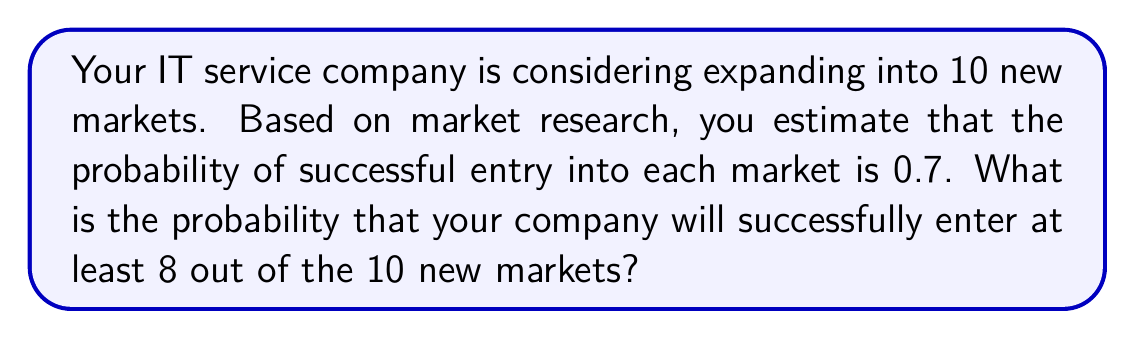Solve this math problem. This problem can be solved using the binomial distribution. Let's break it down step-by-step:

1) We have a binomial distribution with the following parameters:
   $n = 10$ (number of trials/markets)
   $p = 0.7$ (probability of success for each market)
   $q = 1 - p = 0.3$ (probability of failure for each market)

2) We want to find the probability of at least 8 successes. This means we need to calculate:
   $P(X \geq 8) = P(X = 8) + P(X = 9) + P(X = 10)$

3) The probability mass function for a binomial distribution is:
   $P(X = k) = \binom{n}{k} p^k q^{n-k}$

4) Let's calculate each probability:

   For $X = 8$:
   $P(X = 8) = \binom{10}{8} (0.7)^8 (0.3)^2 = 45 \times 0.0576 \times 0.09 = 0.2333$

   For $X = 9$:
   $P(X = 9) = \binom{10}{9} (0.7)^9 (0.3)^1 = 10 \times 0.0404 \times 0.3 = 0.1212$

   For $X = 10$:
   $P(X = 10) = \binom{10}{10} (0.7)^{10} (0.3)^0 = 1 \times 0.0282 \times 1 = 0.0282$

5) Now, we sum these probabilities:
   $P(X \geq 8) = 0.2333 + 0.1212 + 0.0282 = 0.3827$

Therefore, the probability of successfully entering at least 8 out of 10 new markets is approximately 0.3827 or 38.27%.
Answer: $P(X \geq 8) = 0.3827$ or $38.27\%$ 